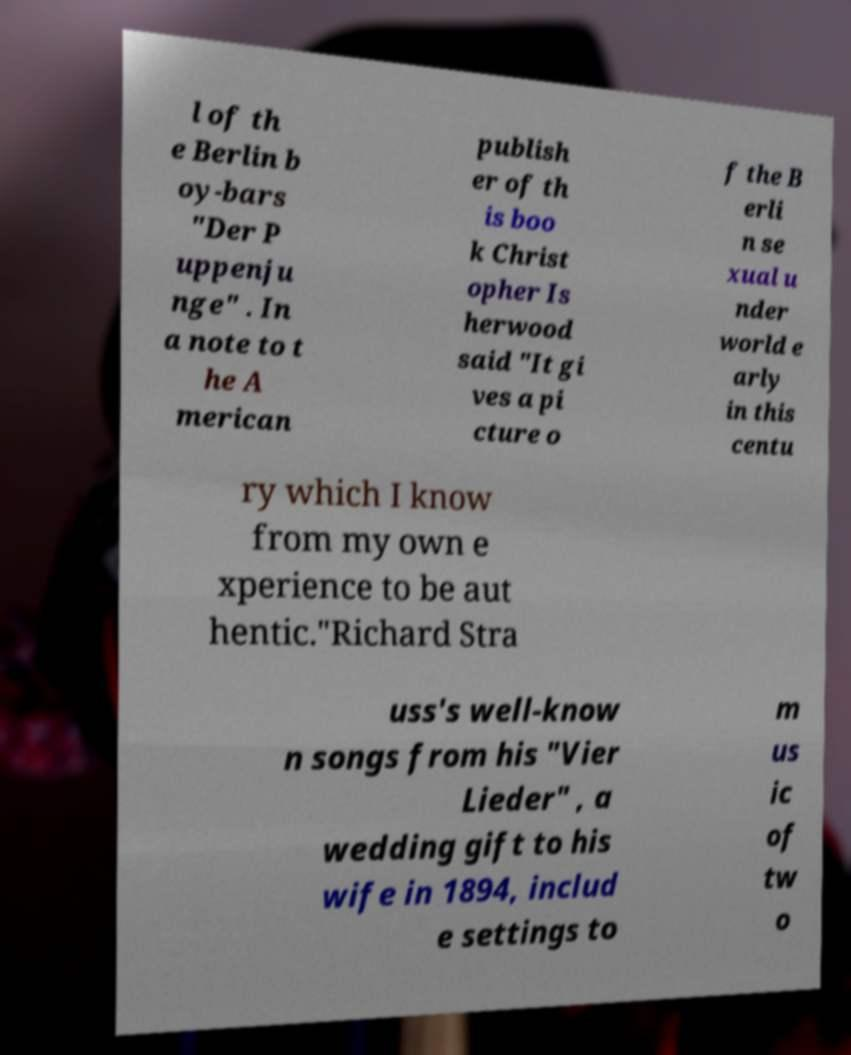There's text embedded in this image that I need extracted. Can you transcribe it verbatim? l of th e Berlin b oy-bars "Der P uppenju nge" . In a note to t he A merican publish er of th is boo k Christ opher Is herwood said "It gi ves a pi cture o f the B erli n se xual u nder world e arly in this centu ry which I know from my own e xperience to be aut hentic."Richard Stra uss's well-know n songs from his "Vier Lieder" , a wedding gift to his wife in 1894, includ e settings to m us ic of tw o 